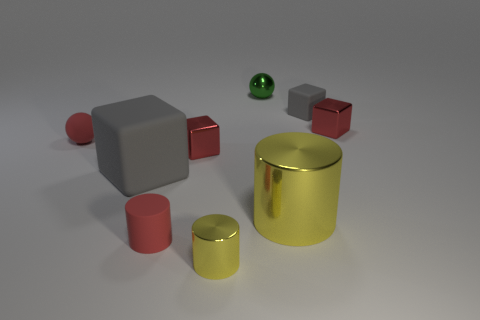How many other things are there of the same size as the green thing?
Make the answer very short. 6. There is a small block that is in front of the red cube on the right side of the metallic cube left of the small yellow metallic thing; what is its color?
Your answer should be compact. Red. What shape is the metal thing that is both behind the red ball and in front of the small green metallic ball?
Give a very brief answer. Cube. How many other objects are the same shape as the green shiny thing?
Your answer should be very brief. 1. The red thing right of the gray matte block that is behind the sphere that is in front of the tiny gray object is what shape?
Give a very brief answer. Cube. How many things are either metallic things or yellow cylinders that are left of the green ball?
Offer a terse response. 5. Is the shape of the tiny red rubber object that is behind the red cylinder the same as the green metallic object that is behind the rubber sphere?
Your response must be concise. Yes. What number of things are big yellow objects or rubber things?
Your response must be concise. 5. Is there a small gray block?
Make the answer very short. Yes. Are the sphere that is in front of the small metallic ball and the red cylinder made of the same material?
Offer a terse response. Yes. 